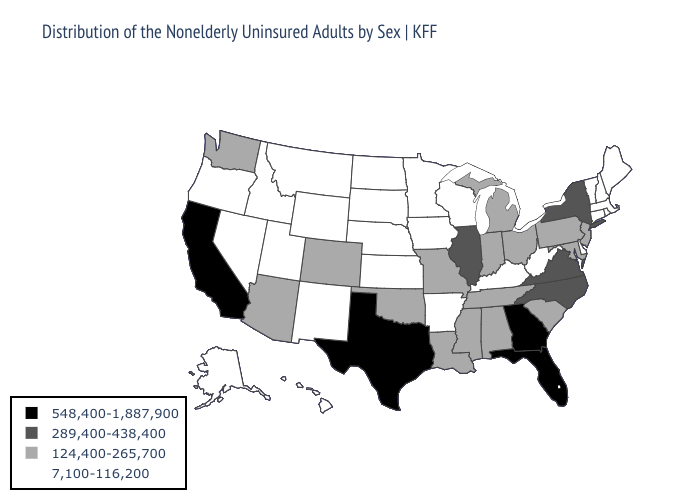What is the value of Utah?
Be succinct. 7,100-116,200. Does Wyoming have the same value as Rhode Island?
Concise answer only. Yes. Name the states that have a value in the range 548,400-1,887,900?
Write a very short answer. California, Florida, Georgia, Texas. Does Washington have the lowest value in the West?
Be succinct. No. Name the states that have a value in the range 548,400-1,887,900?
Answer briefly. California, Florida, Georgia, Texas. Name the states that have a value in the range 7,100-116,200?
Give a very brief answer. Alaska, Arkansas, Connecticut, Delaware, Hawaii, Idaho, Iowa, Kansas, Kentucky, Maine, Massachusetts, Minnesota, Montana, Nebraska, Nevada, New Hampshire, New Mexico, North Dakota, Oregon, Rhode Island, South Dakota, Utah, Vermont, West Virginia, Wisconsin, Wyoming. What is the value of Georgia?
Quick response, please. 548,400-1,887,900. Name the states that have a value in the range 124,400-265,700?
Answer briefly. Alabama, Arizona, Colorado, Indiana, Louisiana, Maryland, Michigan, Mississippi, Missouri, New Jersey, Ohio, Oklahoma, Pennsylvania, South Carolina, Tennessee, Washington. What is the value of Colorado?
Be succinct. 124,400-265,700. Name the states that have a value in the range 7,100-116,200?
Quick response, please. Alaska, Arkansas, Connecticut, Delaware, Hawaii, Idaho, Iowa, Kansas, Kentucky, Maine, Massachusetts, Minnesota, Montana, Nebraska, Nevada, New Hampshire, New Mexico, North Dakota, Oregon, Rhode Island, South Dakota, Utah, Vermont, West Virginia, Wisconsin, Wyoming. Which states have the lowest value in the USA?
Quick response, please. Alaska, Arkansas, Connecticut, Delaware, Hawaii, Idaho, Iowa, Kansas, Kentucky, Maine, Massachusetts, Minnesota, Montana, Nebraska, Nevada, New Hampshire, New Mexico, North Dakota, Oregon, Rhode Island, South Dakota, Utah, Vermont, West Virginia, Wisconsin, Wyoming. What is the value of Mississippi?
Give a very brief answer. 124,400-265,700. Among the states that border Nebraska , which have the lowest value?
Answer briefly. Iowa, Kansas, South Dakota, Wyoming. Name the states that have a value in the range 7,100-116,200?
Keep it brief. Alaska, Arkansas, Connecticut, Delaware, Hawaii, Idaho, Iowa, Kansas, Kentucky, Maine, Massachusetts, Minnesota, Montana, Nebraska, Nevada, New Hampshire, New Mexico, North Dakota, Oregon, Rhode Island, South Dakota, Utah, Vermont, West Virginia, Wisconsin, Wyoming. What is the value of Virginia?
Keep it brief. 289,400-438,400. 